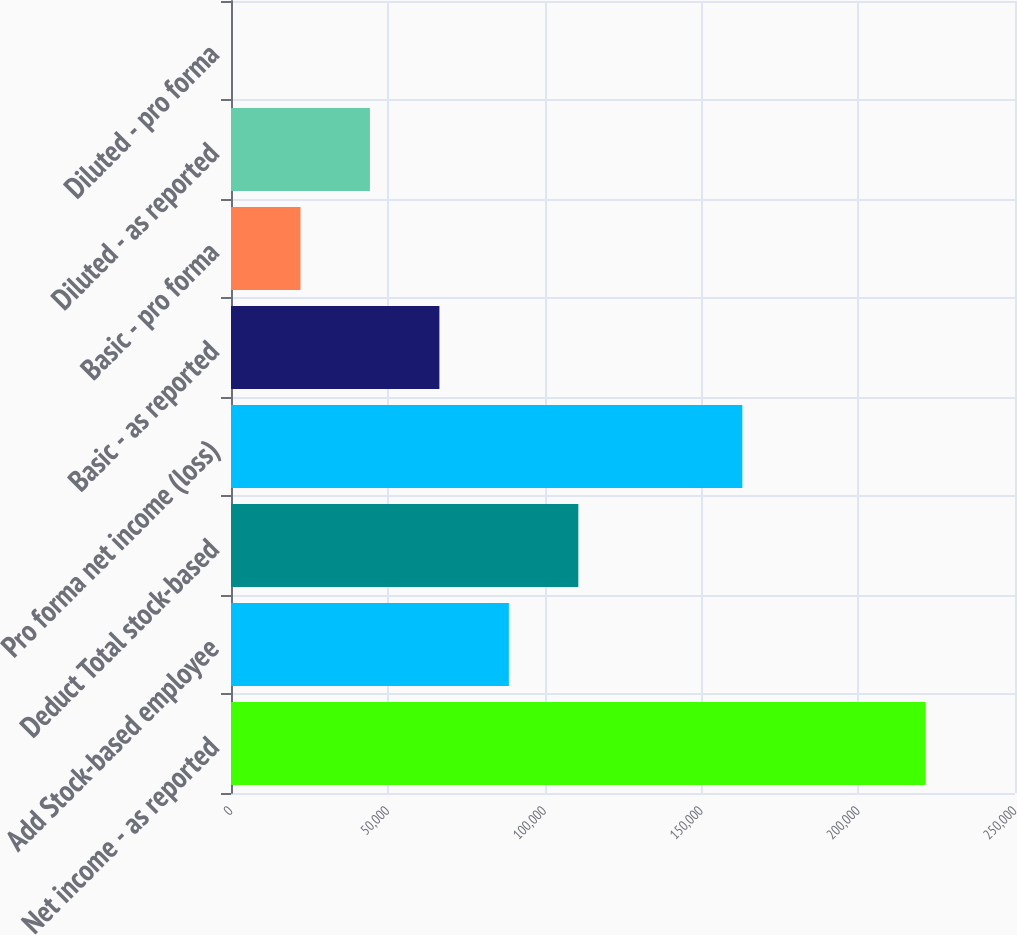Convert chart to OTSL. <chart><loc_0><loc_0><loc_500><loc_500><bar_chart><fcel>Net income - as reported<fcel>Add Stock-based employee<fcel>Deduct Total stock-based<fcel>Pro forma net income (loss)<fcel>Basic - as reported<fcel>Basic - pro forma<fcel>Diluted - as reported<fcel>Diluted - pro forma<nl><fcel>221508<fcel>88603.6<fcel>110754<fcel>163059<fcel>66452.9<fcel>22151.4<fcel>44302.1<fcel>0.67<nl></chart> 